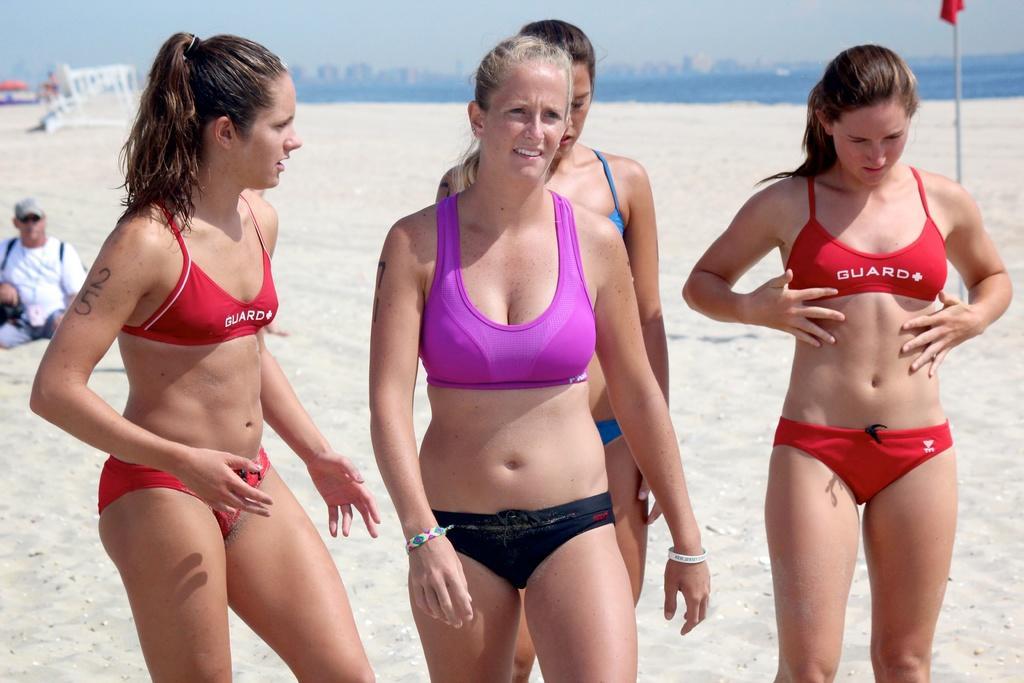Can you describe this image briefly? In this image, there are a few people. Among them, we can see a person sitting. We can see the ground covered with sand and some objects. We can also see some water and the sky. There are a few buildings. 